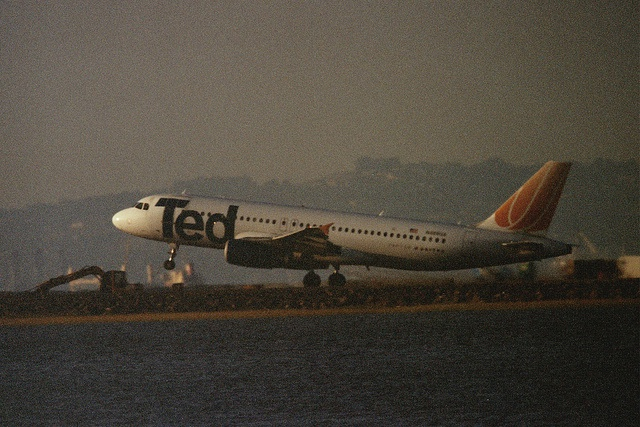Describe the objects in this image and their specific colors. I can see a airplane in gray and black tones in this image. 